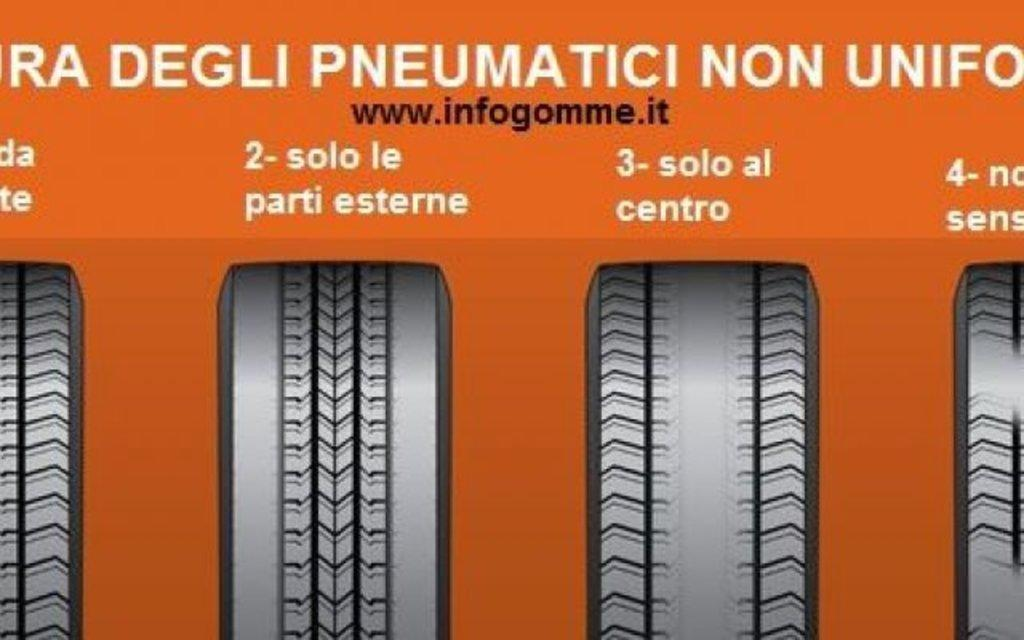What color is the background of the poster in the image? The poster has an orange background. What can be found on the poster besides the background color? There is text written on the poster. What objects are visible in the image? There are tires in the image. What type of substance is being measured in the image? There is no substance being measured in the image; it features a poster with an orange background, text, and tires. What angle is the tire leaning at in the image? The angle at which the tires are leaning cannot be determined from the image, as they appear to be flat on the ground. 